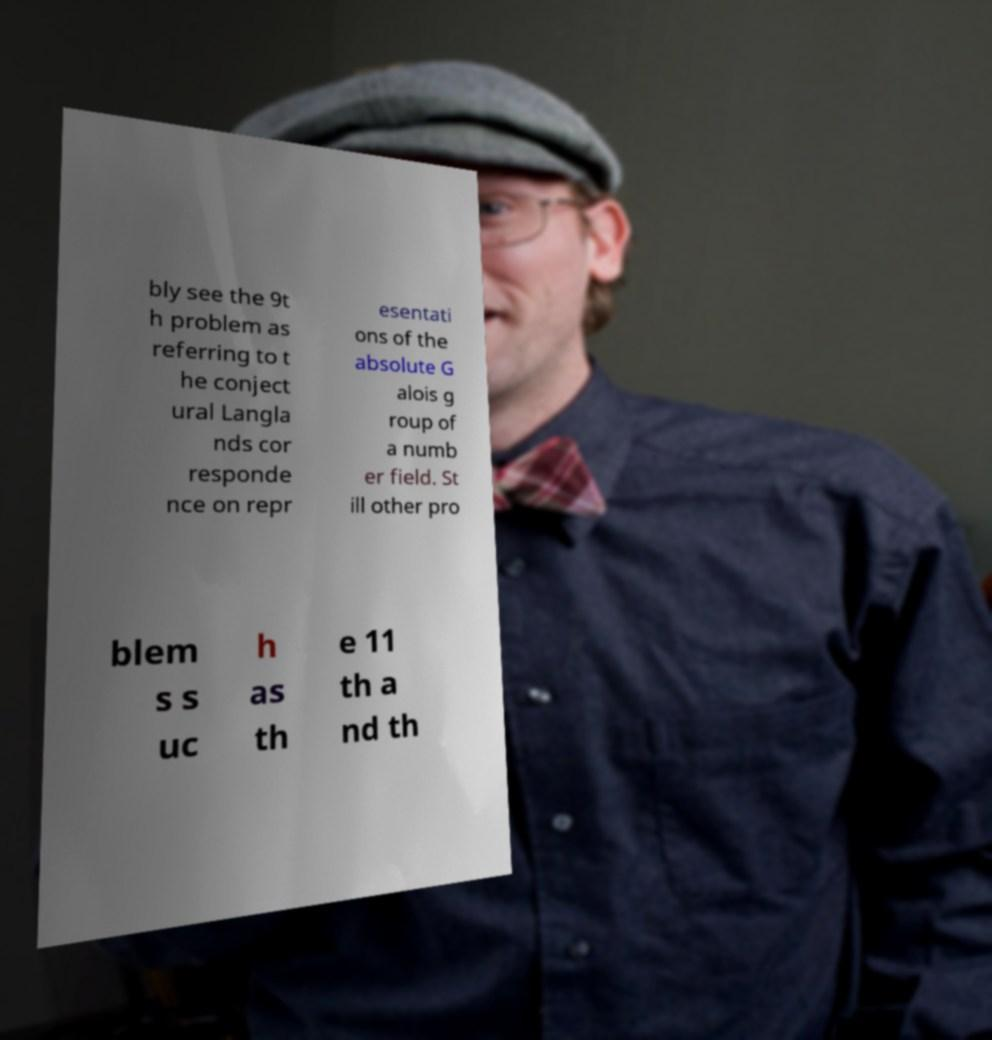What messages or text are displayed in this image? I need them in a readable, typed format. bly see the 9t h problem as referring to t he conject ural Langla nds cor responde nce on repr esentati ons of the absolute G alois g roup of a numb er field. St ill other pro blem s s uc h as th e 11 th a nd th 